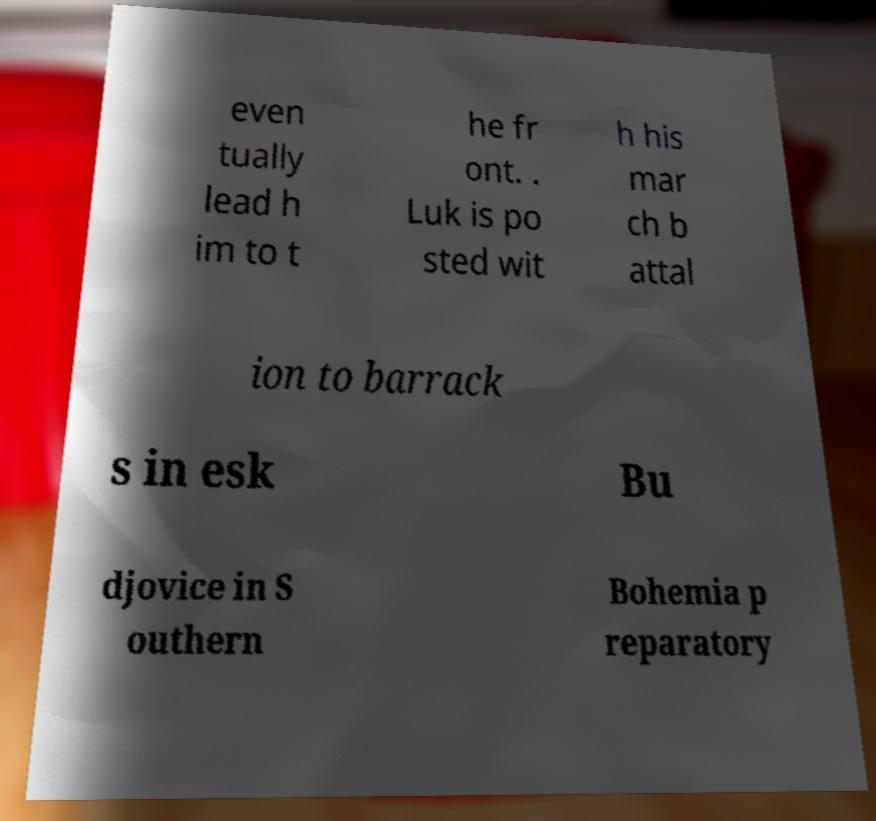I need the written content from this picture converted into text. Can you do that? even tually lead h im to t he fr ont. . Luk is po sted wit h his mar ch b attal ion to barrack s in esk Bu djovice in S outhern Bohemia p reparatory 